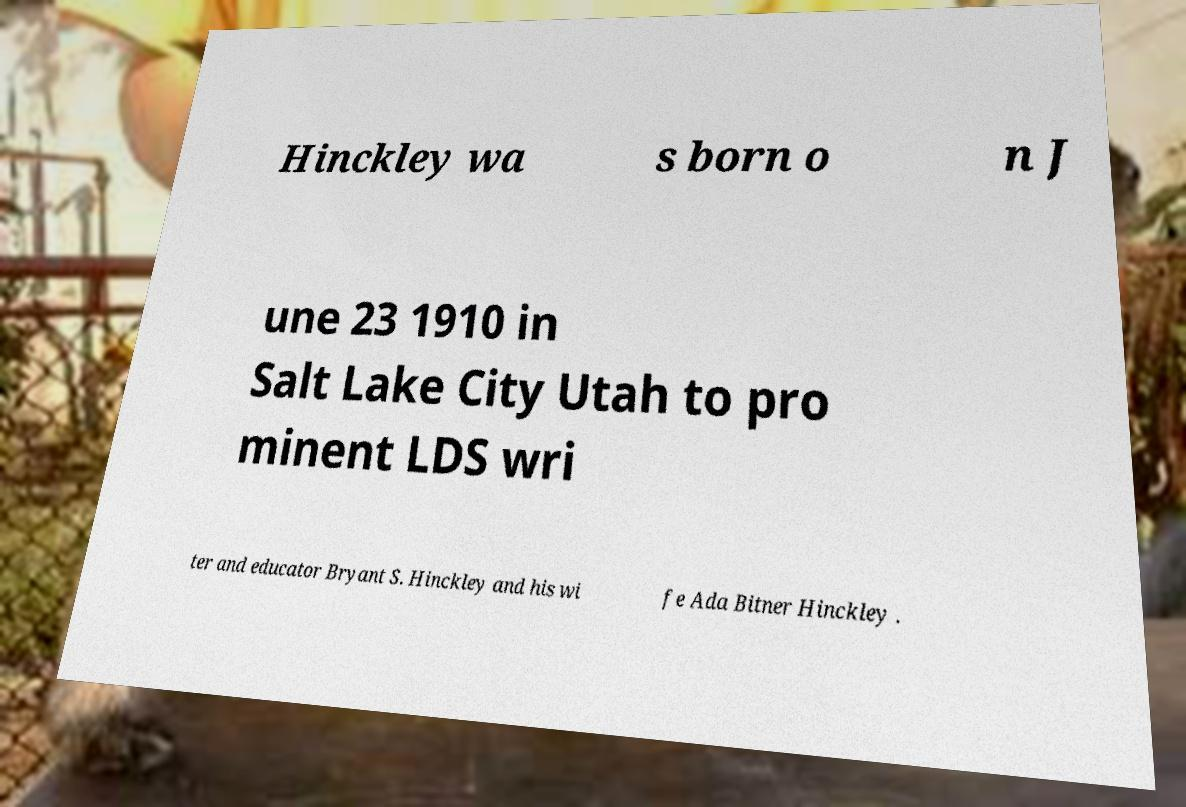Please identify and transcribe the text found in this image. Hinckley wa s born o n J une 23 1910 in Salt Lake City Utah to pro minent LDS wri ter and educator Bryant S. Hinckley and his wi fe Ada Bitner Hinckley . 